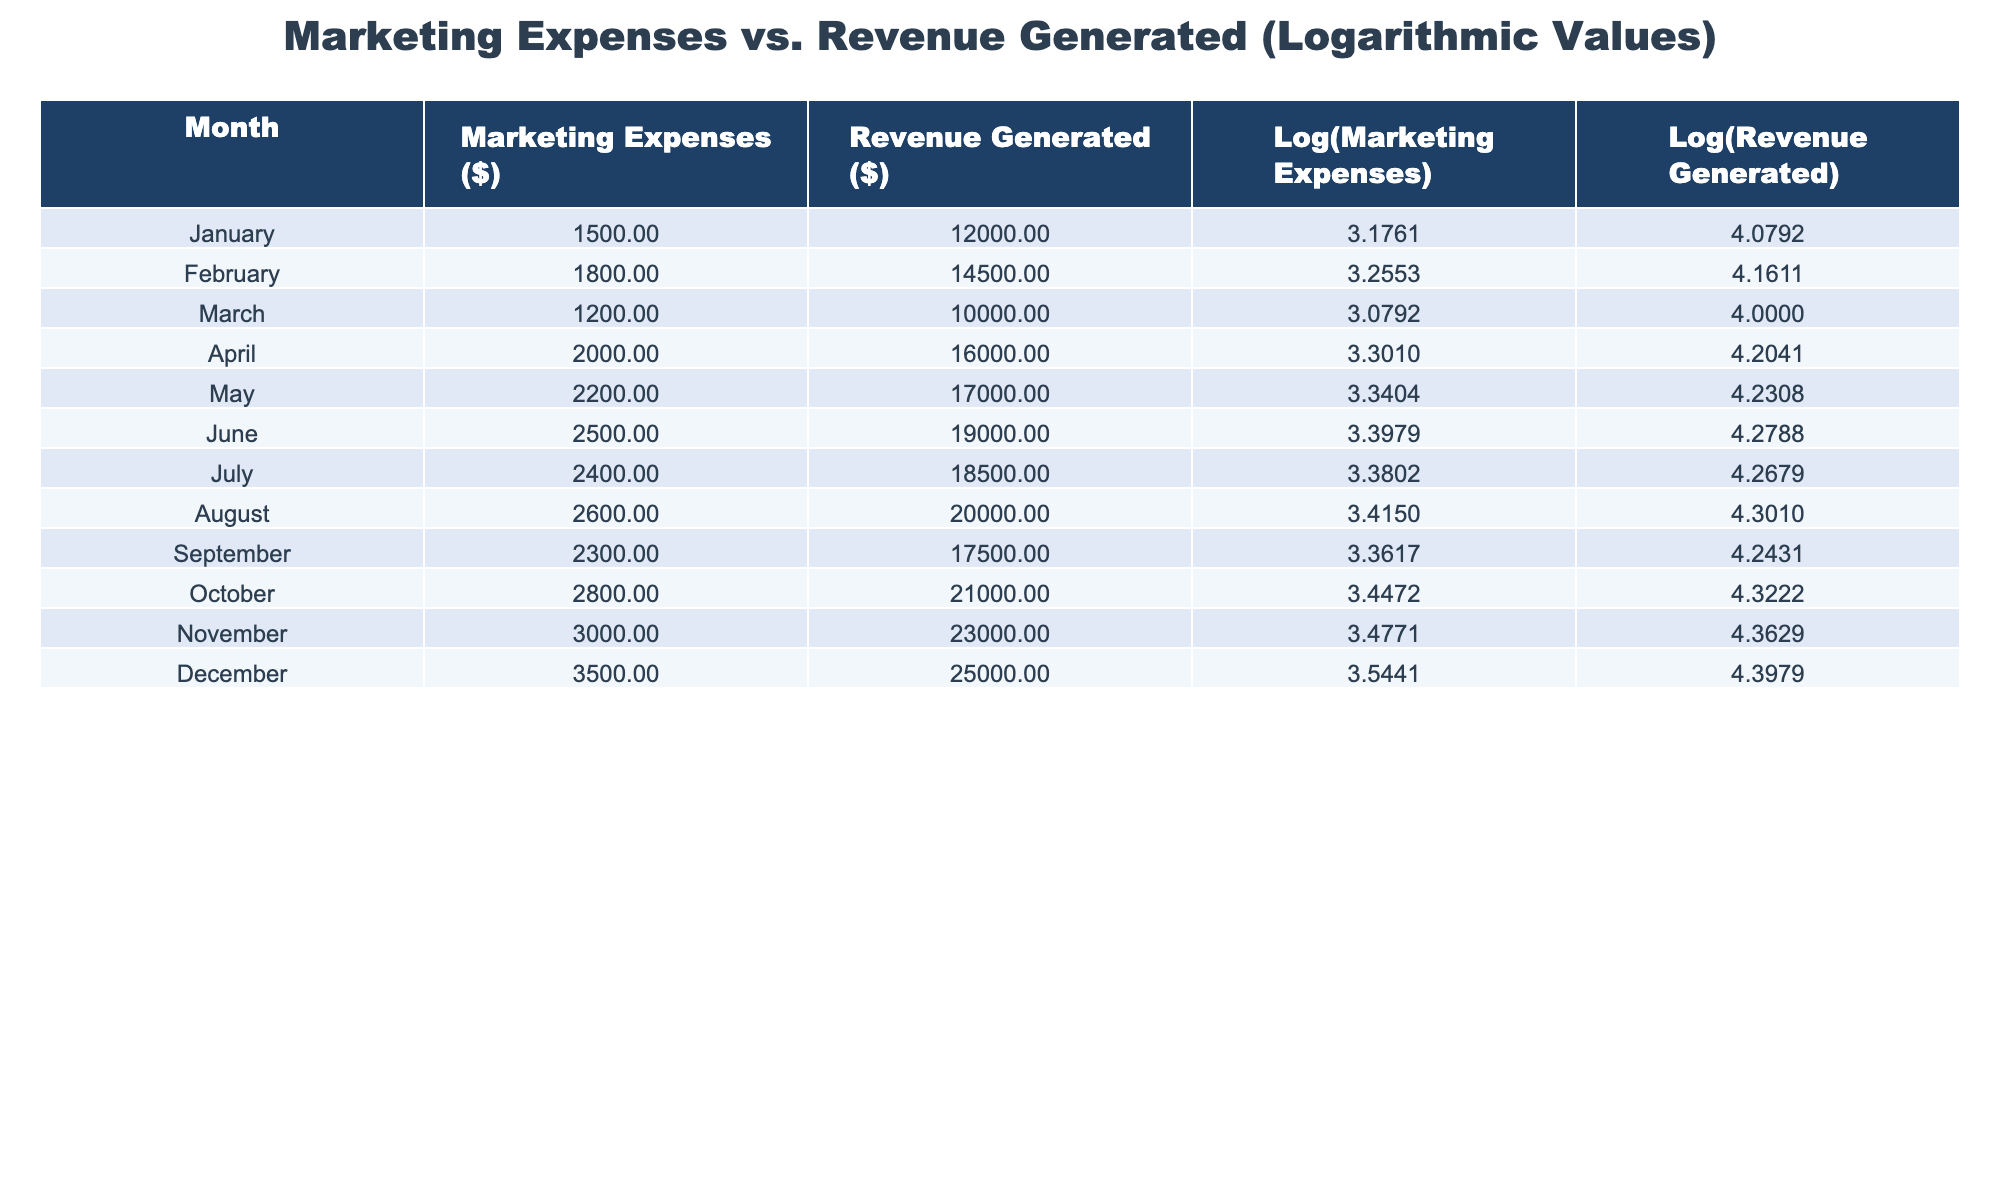What were the marketing expenses in October? According to the table, the marketing expenses in October are explicitly listed as $2800.
Answer: 2800 What is the revenue generated in December? The revenue generated in December can be directly found in the table, which states it is $25000.
Answer: 25000 Which month had the highest marketing expenses? By reviewing the "Marketing Expenses" column, December shows the highest value of $3500, which is greater than all other months.
Answer: December What is the average revenue generated over the year? To find the average revenue, sum all monthly revenue values: 12000 + 14500 + 10000 + 16000 + 17000 + 19000 + 18500 + 20000 + 17500 + 21000 + 23000 + 25000 =  206000. Divide this by 12 (the number of months), giving 206000 / 12 = 17166.67.
Answer: 17166.67 Did the marketing expenses increase every month? Upon examining each row in the "Marketing Expenses" column, January starts with $1500, then increases in every following month until December, confirming that expenses did consistently rise.
Answer: Yes If marketing expenses in January were doubled, what would they be? January's marketing expenses are $1500. Doubling this amount results in 2 * 1500 = $3000.
Answer: 3000 What is the difference in revenue generated between April and August? The revenue generated in April is $16000 and in August is $20000. Calculating the difference involves subtracting: 20000 - 16000 = $4000.
Answer: 4000 Which month had the lowest revenue generated? Looking at the "Revenue Generated" column, January has the lowest figure at $12000 compared to all other months.
Answer: January What was the logarithmic value of marketing expenses in July? The table directly provides the logarithmic value of marketing expenses for July as 3.3802.
Answer: 3.3802 